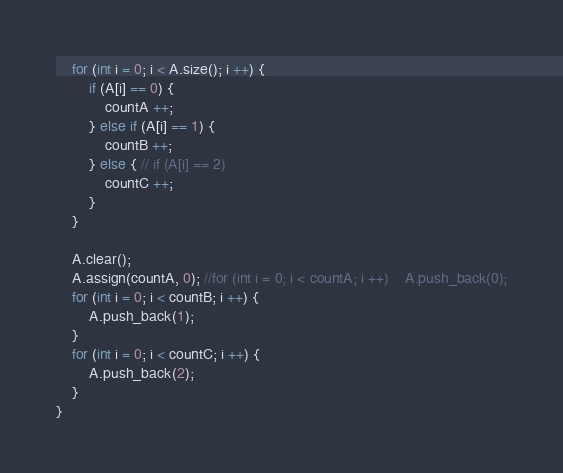Convert code to text. <code><loc_0><loc_0><loc_500><loc_500><_C++_>    for (int i = 0; i < A.size(); i ++) {
        if (A[i] == 0) {
            countA ++;
        } else if (A[i] == 1) {
            countB ++;
        } else { // if (A[i] == 2)
            countC ++;
        }
    }
    
    A.clear();
    A.assign(countA, 0); //for (int i = 0; i < countA; i ++)    A.push_back(0);
    for (int i = 0; i < countB; i ++) {
        A.push_back(1);
    }
    for (int i = 0; i < countC; i ++) {
        A.push_back(2);
    }
}
</code> 